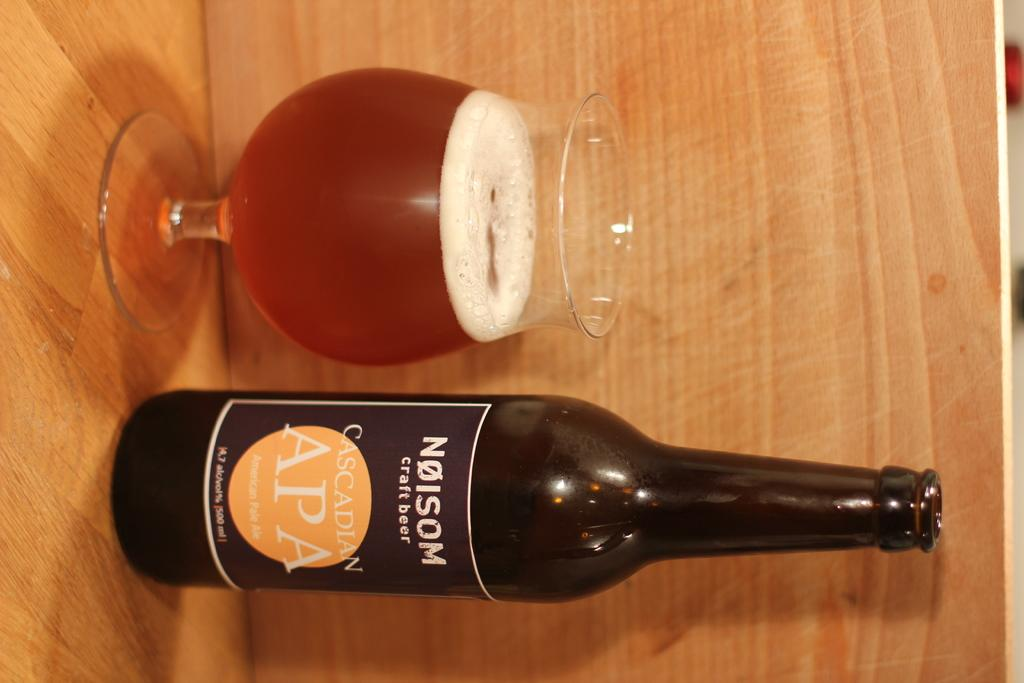<image>
Give a short and clear explanation of the subsequent image. A bottle of Nolsom Cascadian Ale is next to a glass. 